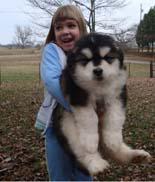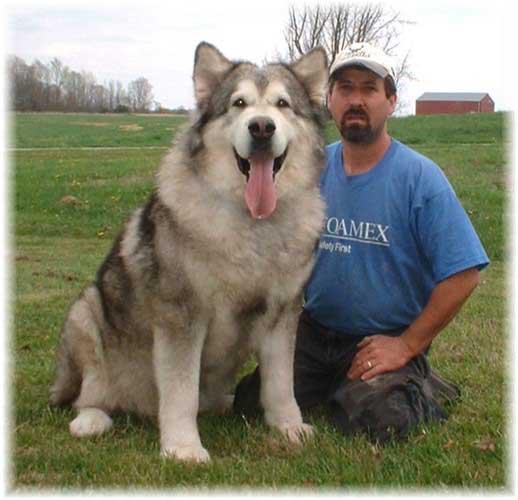The first image is the image on the left, the second image is the image on the right. Evaluate the accuracy of this statement regarding the images: "There are exactly two dogs and two people.". Is it true? Answer yes or no. Yes. The first image is the image on the left, the second image is the image on the right. For the images displayed, is the sentence "There are exactly two dogs in total." factually correct? Answer yes or no. Yes. 